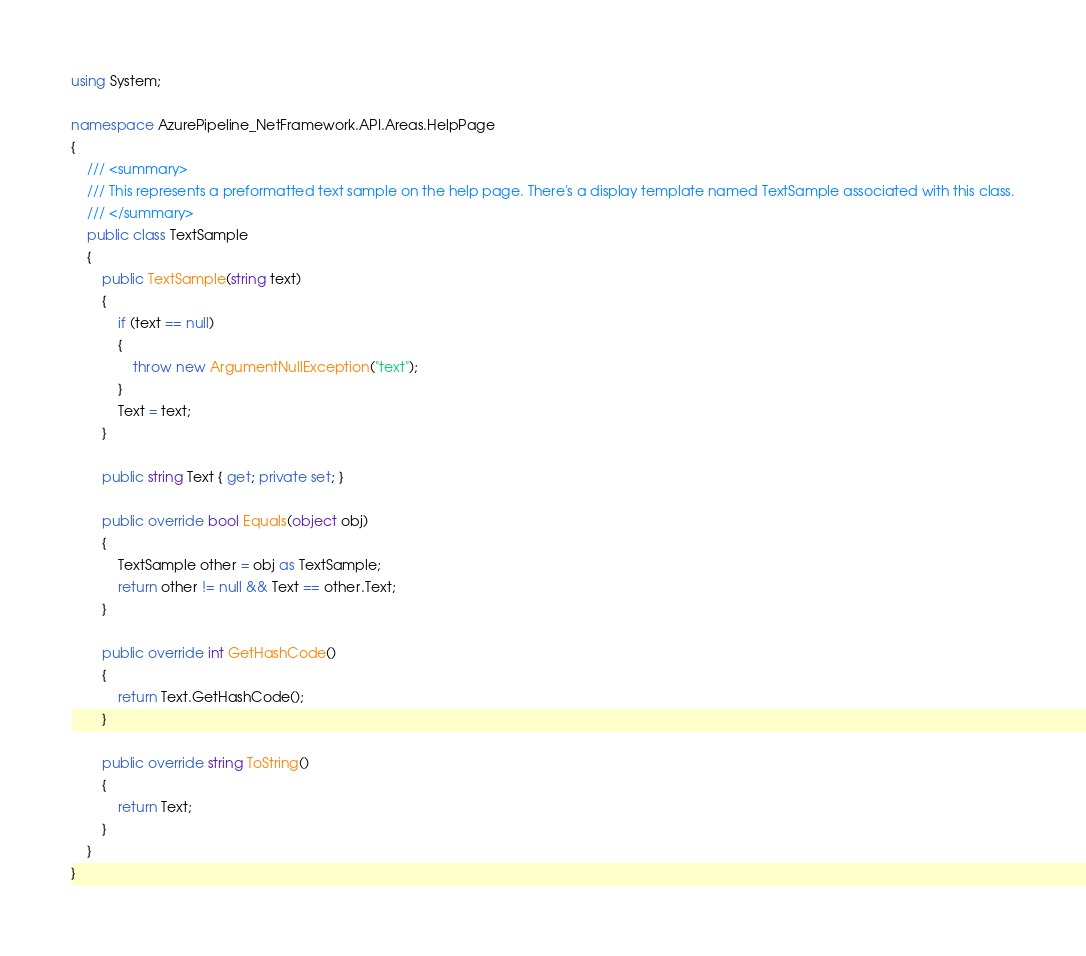Convert code to text. <code><loc_0><loc_0><loc_500><loc_500><_C#_>using System;

namespace AzurePipeline_NetFramework.API.Areas.HelpPage
{
    /// <summary>
    /// This represents a preformatted text sample on the help page. There's a display template named TextSample associated with this class.
    /// </summary>
    public class TextSample
    {
        public TextSample(string text)
        {
            if (text == null)
            {
                throw new ArgumentNullException("text");
            }
            Text = text;
        }

        public string Text { get; private set; }

        public override bool Equals(object obj)
        {
            TextSample other = obj as TextSample;
            return other != null && Text == other.Text;
        }

        public override int GetHashCode()
        {
            return Text.GetHashCode();
        }

        public override string ToString()
        {
            return Text;
        }
    }
}</code> 